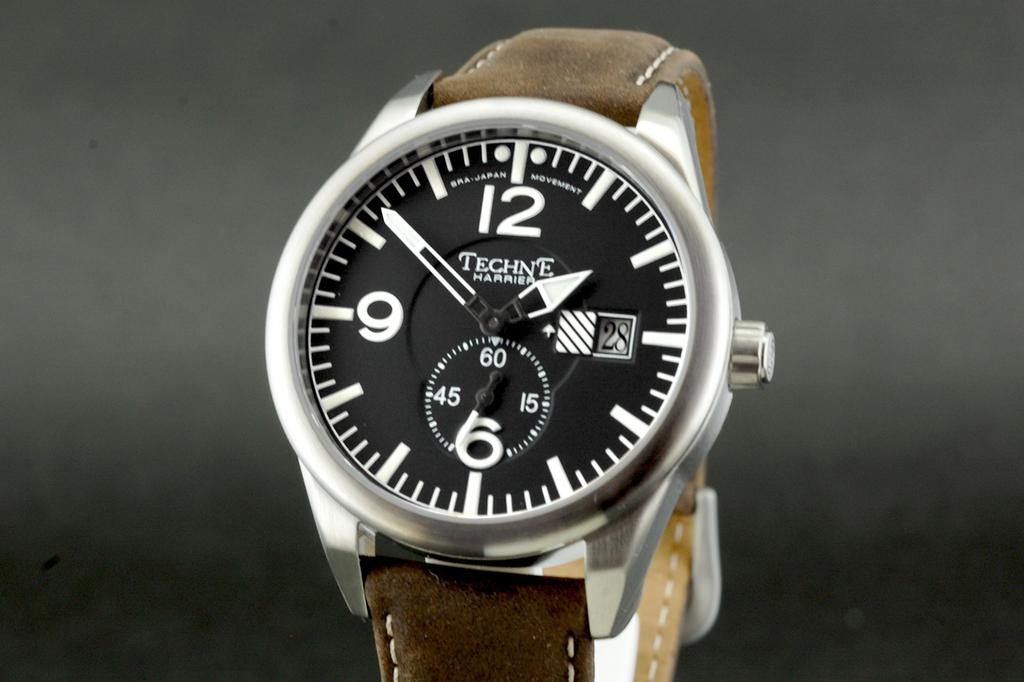<image>
Describe the image concisely. a Techne Harrier watch with a big face and leather strap 